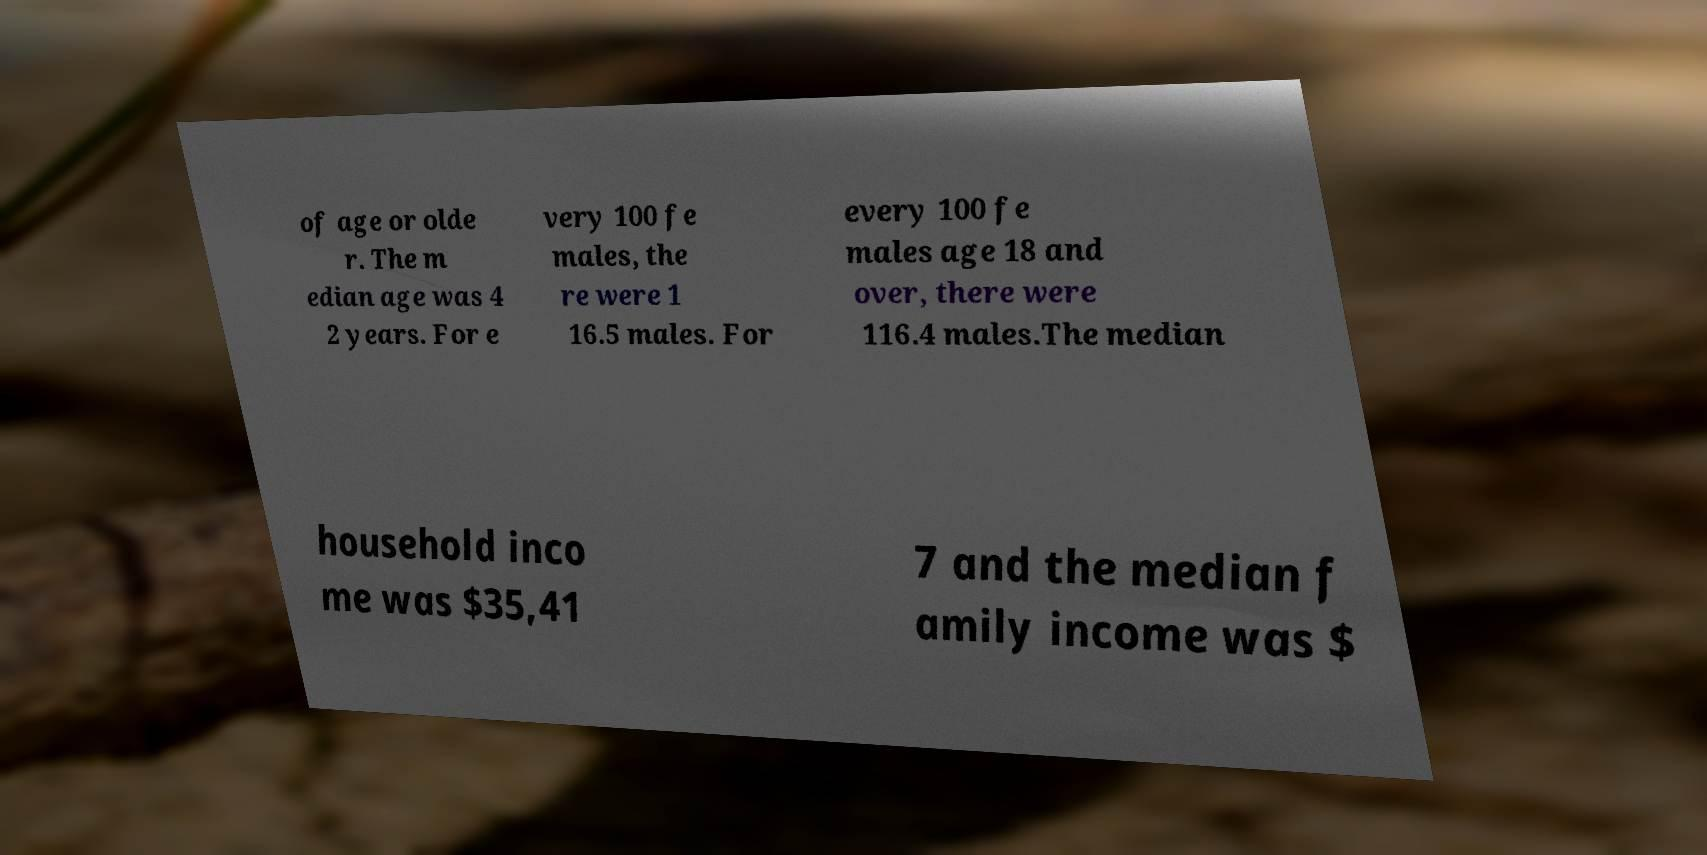Please read and relay the text visible in this image. What does it say? of age or olde r. The m edian age was 4 2 years. For e very 100 fe males, the re were 1 16.5 males. For every 100 fe males age 18 and over, there were 116.4 males.The median household inco me was $35,41 7 and the median f amily income was $ 